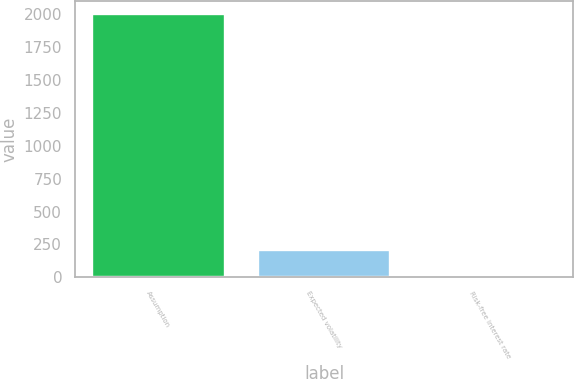<chart> <loc_0><loc_0><loc_500><loc_500><bar_chart><fcel>Assumption<fcel>Expected volatility<fcel>Risk-free interest rate<nl><fcel>2001<fcel>204.28<fcel>4.65<nl></chart> 